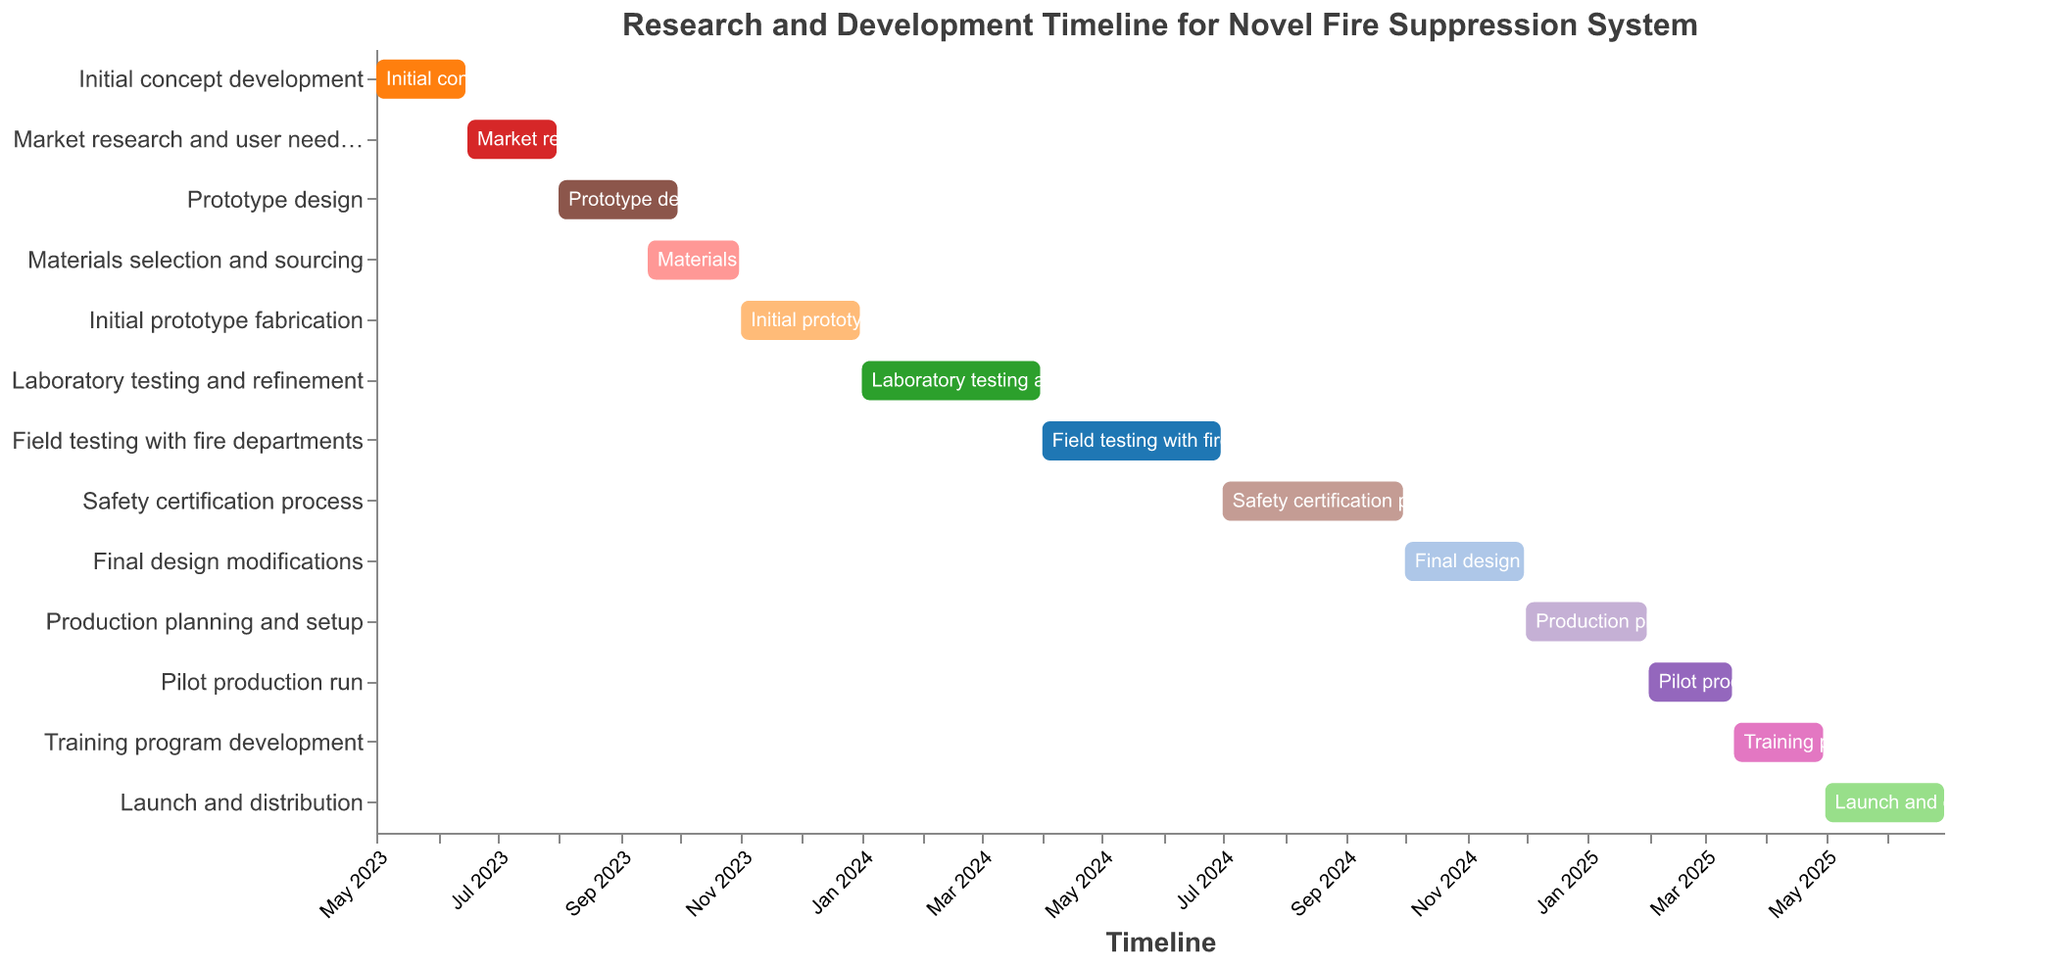What is the title of the chart? The title of the chart is displayed at the top in the center. It states the purpose or subject of the chart.
Answer: Research and Development Timeline for Novel Fire Suppression System Which task has the earliest start date and what is it? To find the earliest start date, identify the leftmost starting bar on the chart.
Answer: Initial concept development How long is the Market research and user needs analysis phase? Find the start and end dates of this task on the x-axis and count the number of days/weeks/months between them.
Answer: 1.5 months Which phase involves working with fire departments? Look for the task that explicitly mentions "fire departments" in its name and check its corresponding position on the y-axis.
Answer: Field testing with fire departments Do any tasks overlap in their timelines? If so, which ones? Examine the x-axis; tasks that have bars starting and ending within the span of other tasks' bars overlap.
Answer: Prototype design and Materials selection and sourcing During which months is the Initial prototype fabrication task conducted? Check the start and end dates of the task and note which months it spans.
Answer: November and December 2023 How long does the Laboratory testing and refinement phase last? Identify the start and end dates and calculate the duration between them.
Answer: 3 months Which tasks are conducted entirely in 2024? Look for tasks that start and end within the calendar year 2024 on the x-axis.
Answer: Laboratory testing and refinement, Field testing with fire departments, Safety certification process, Final design modifications, Production planning and setup What is the duration of the longest task, and which task is it? Compare the durations of all tasks by measuring the length of their bars on the x-axis.
Answer: Market research and user needs analysis; 1.5 months How many tasks have end dates in 2025? Count the number of tasks that have bars ending within the 2025 portion of the x-axis.
Answer: 3 tasks 